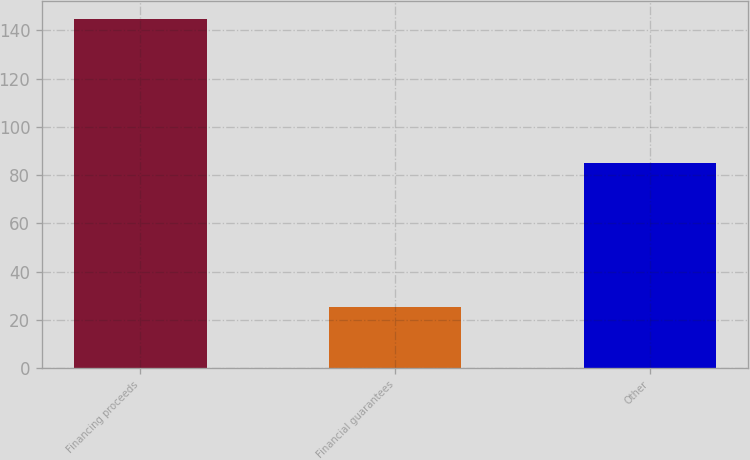<chart> <loc_0><loc_0><loc_500><loc_500><bar_chart><fcel>Financing proceeds<fcel>Financial guarantees<fcel>Other<nl><fcel>144.9<fcel>25.3<fcel>85.1<nl></chart> 